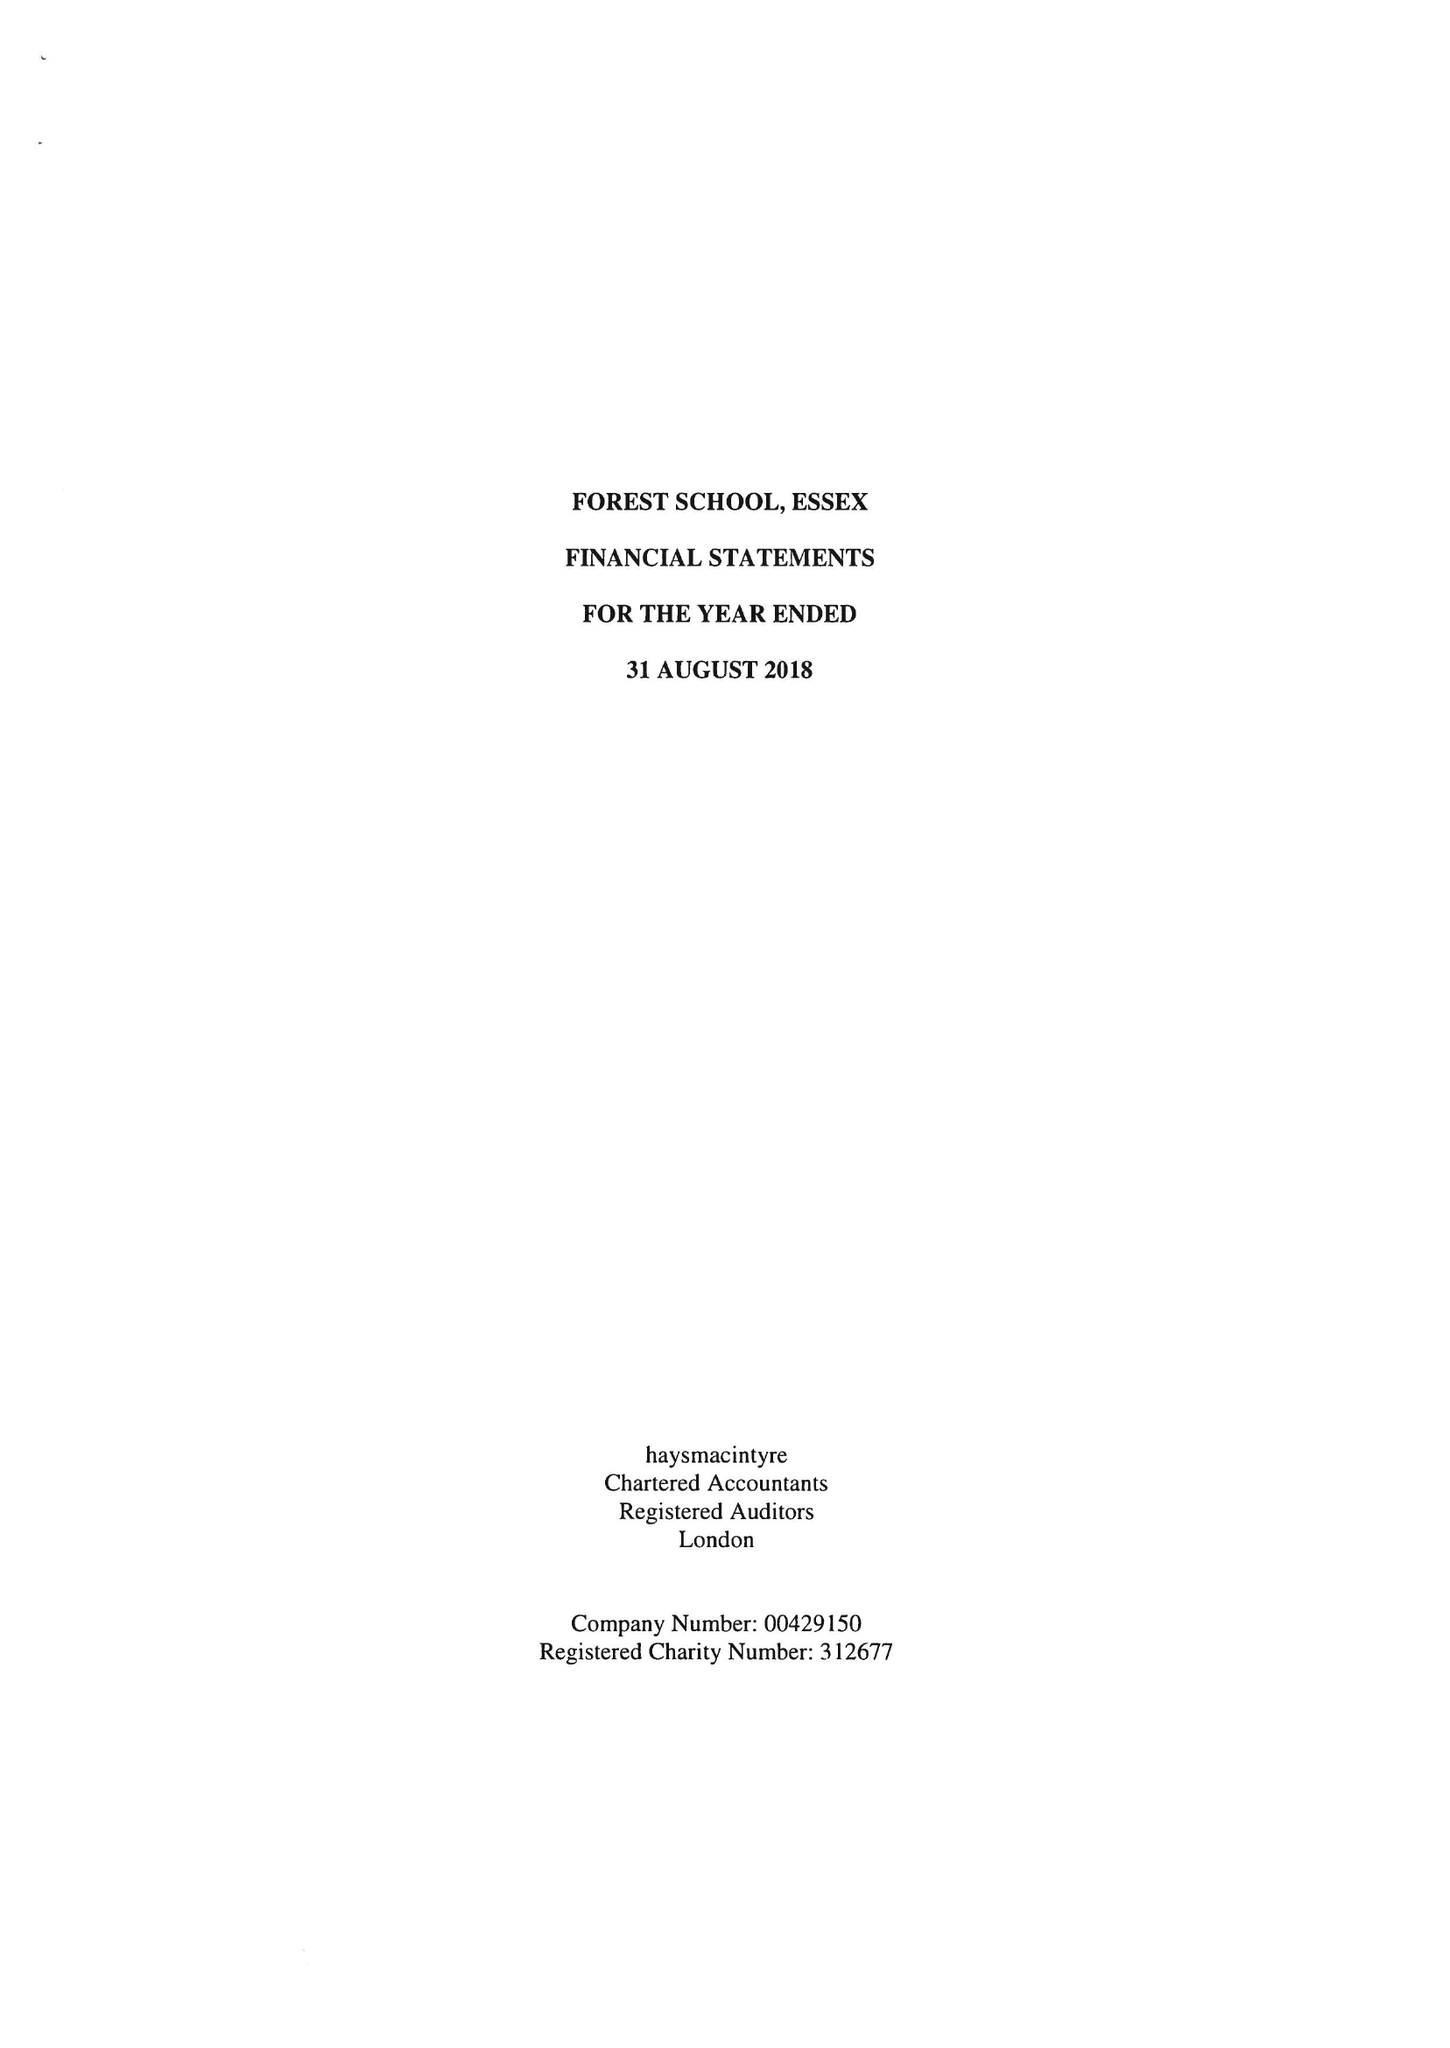What is the value for the address__post_town?
Answer the question using a single word or phrase. LONDON 